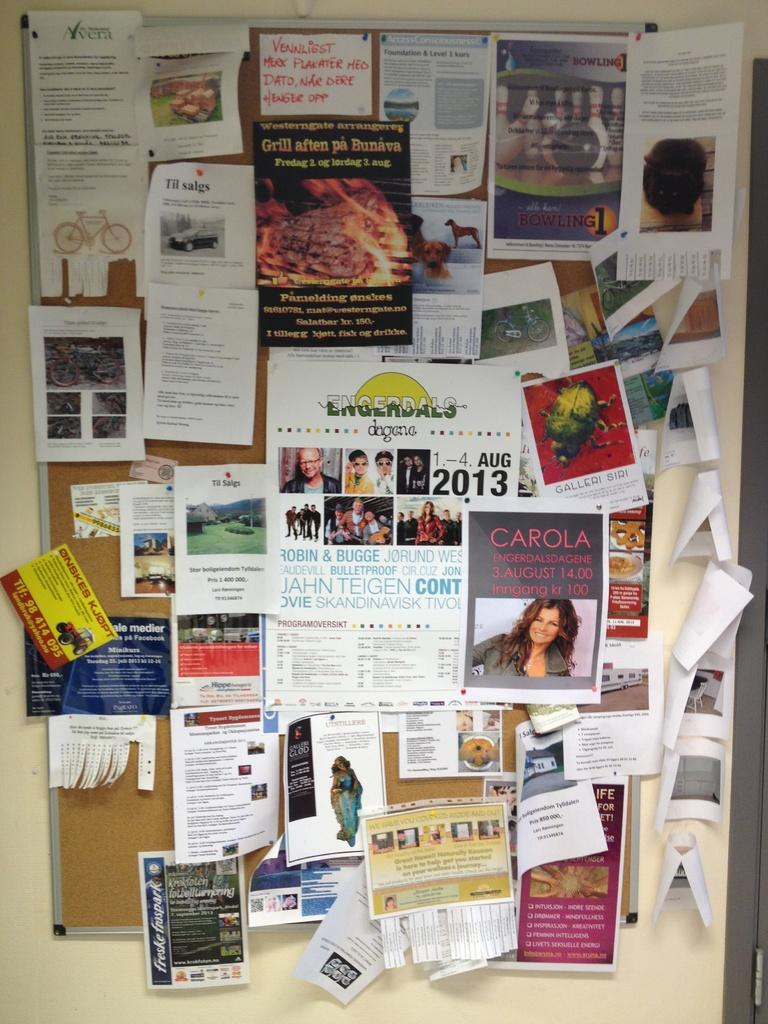<image>
Provide a brief description of the given image. A bulletin board has man flyers, the flyer in the middle is for Engerdals dagene in Aug 2013. 